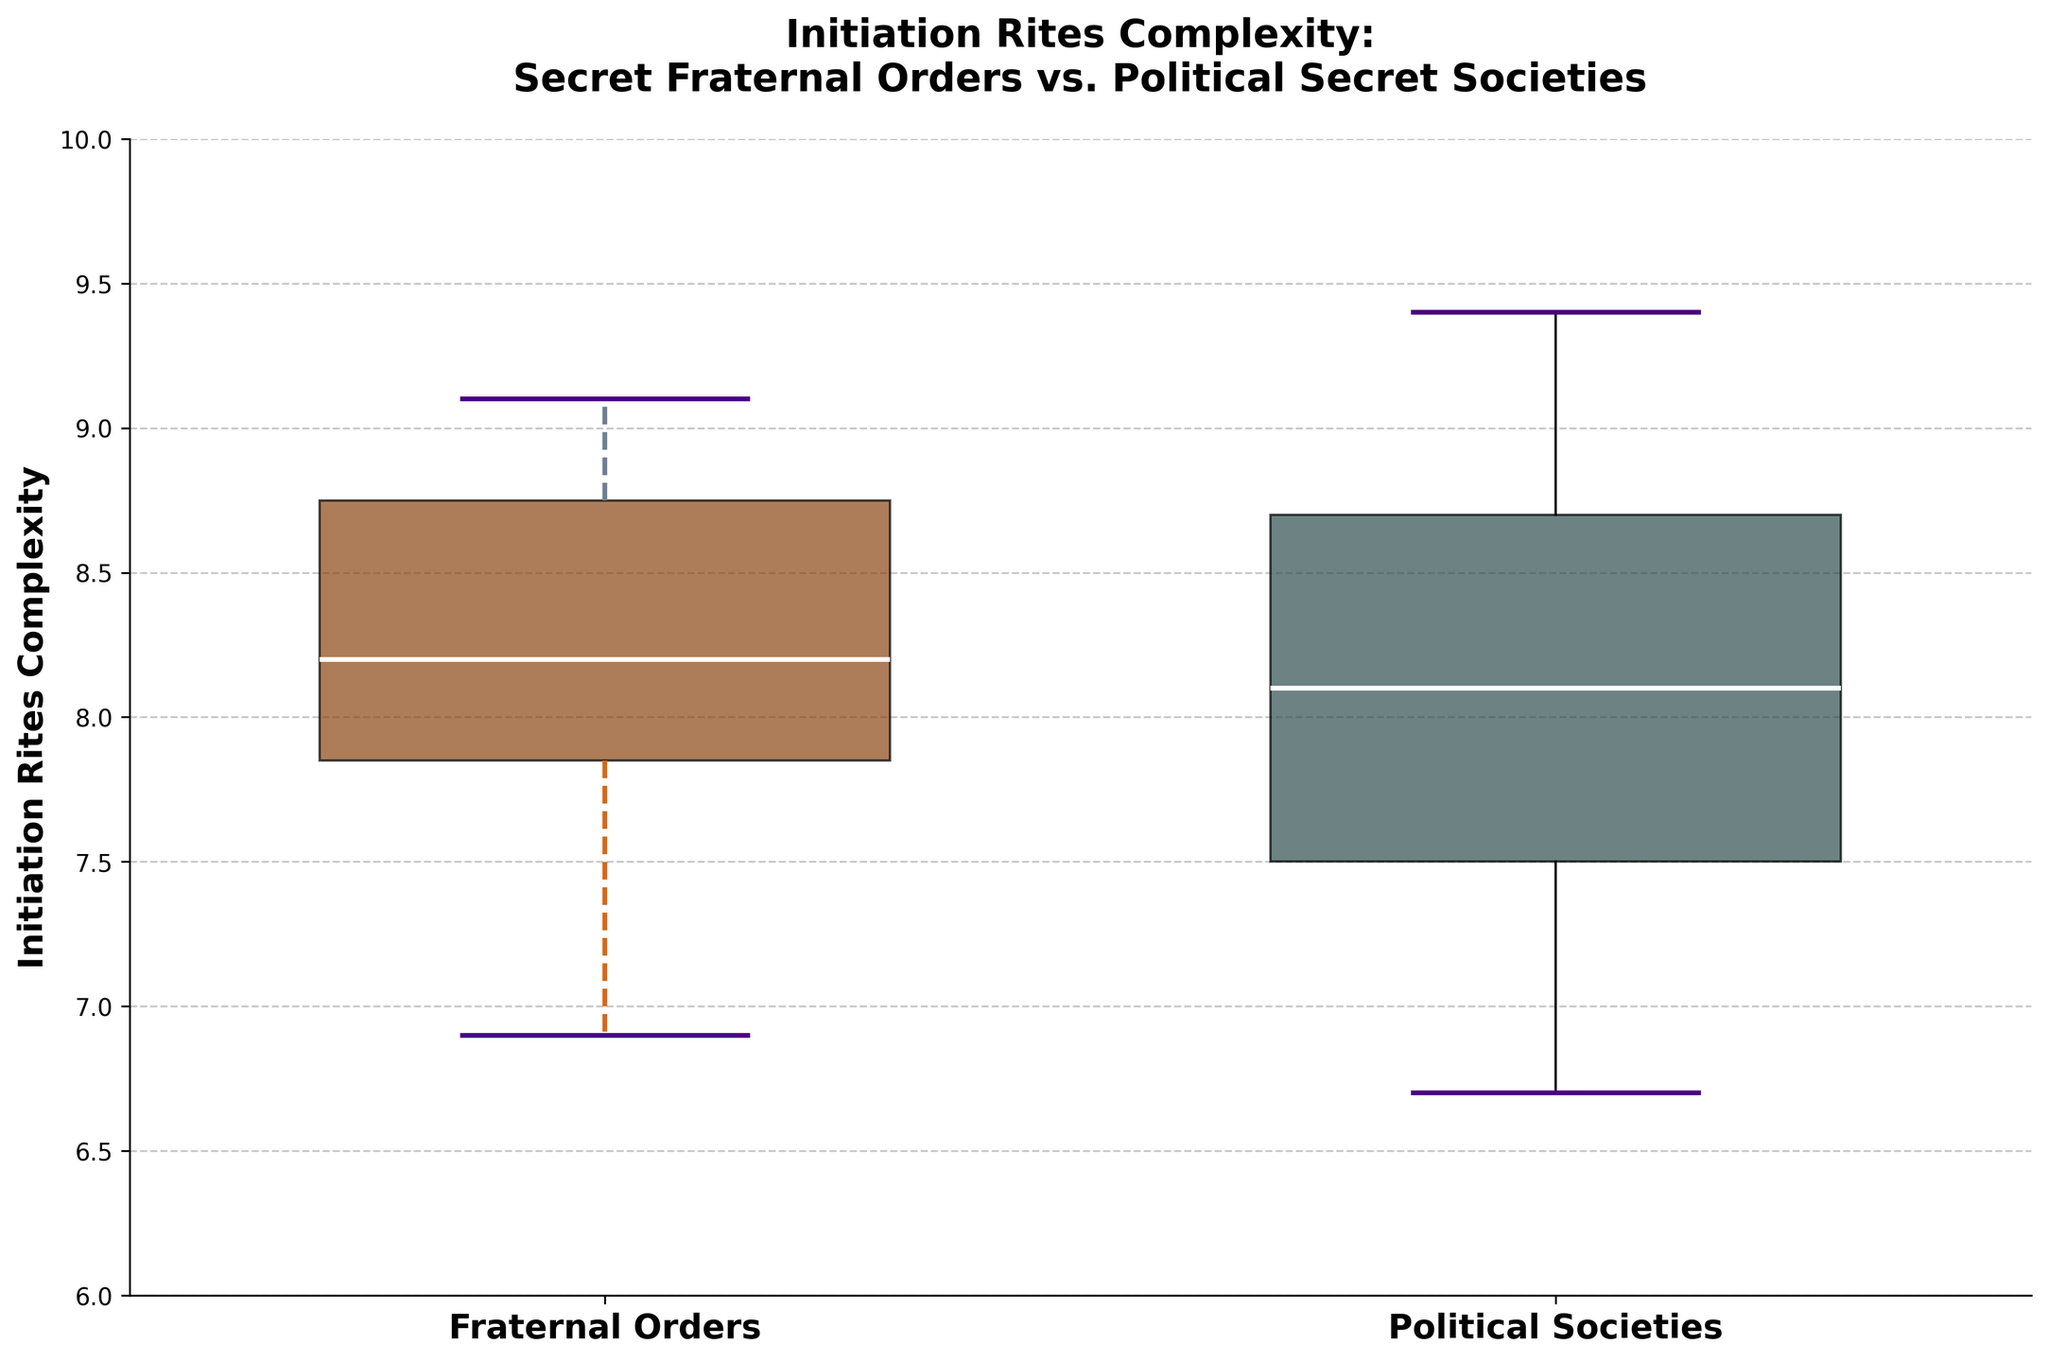What is the title of the plot? The title of the plot is located at the top and provides an overview of what the figure is about.
Answer: Initiation Rites Complexity: Secret Fraternal Orders vs. Political Secret Societies Which group shows a higher median complexity? By examining the horizontal line within each box, which represents the median, we can see the position of the median for both groups.
Answer: Political Societies What is the range of initiation rites complexity for Secret Fraternal Orders? The range is determined by the distance between the lowest and highest whiskers of the box plot for the Fraternal Orders group.
Answer: 6.9 to 9.1 How many distinct groups are depicted in the plot? The x-axis labels indicate the distinct groups portrayed in the box plot.
Answer: 2 Which group has a wider interquartile range (IQR)? The IQR is represented by the height of the box in each group, which is the distance between the first (bottom of the box) and third quartile (top of the box).
Answer: Secret Fraternal Orders What color represents the box plot for Political Secret Societies? The color of the box can be identified by looking at the figure and its legend. The plot script indicates two distinct colors for each group.
Answer: Dark Slate Gray Which group has more data points above the median? By looking at the position of data points relative to the median indicated by the horizontal line inside each box, we can count the number of points above the median in each group.
Answer: Political Secret Societies Does any group show outliers? If so, which group? Outliers are typically indicated by individual points plotted outside the whiskers of the box plots. We observe if any points fall beyond these limits.
Answer: None What is the approximate median complexity for Secret Fraternal Orders? The median is the line within the box representing the central value of data, so we check the location of this line for the Secret Fraternal Orders group.
Answer: 8 What is the lower whisker value for Political Secret Societies? A whisker in a box plot extends to the minimum value within 1.5 times the interquartile range (IQR) from the quartiles. We identify the lowest point connected by the whisker for Political Secret Societies.
Answer: 7.5 